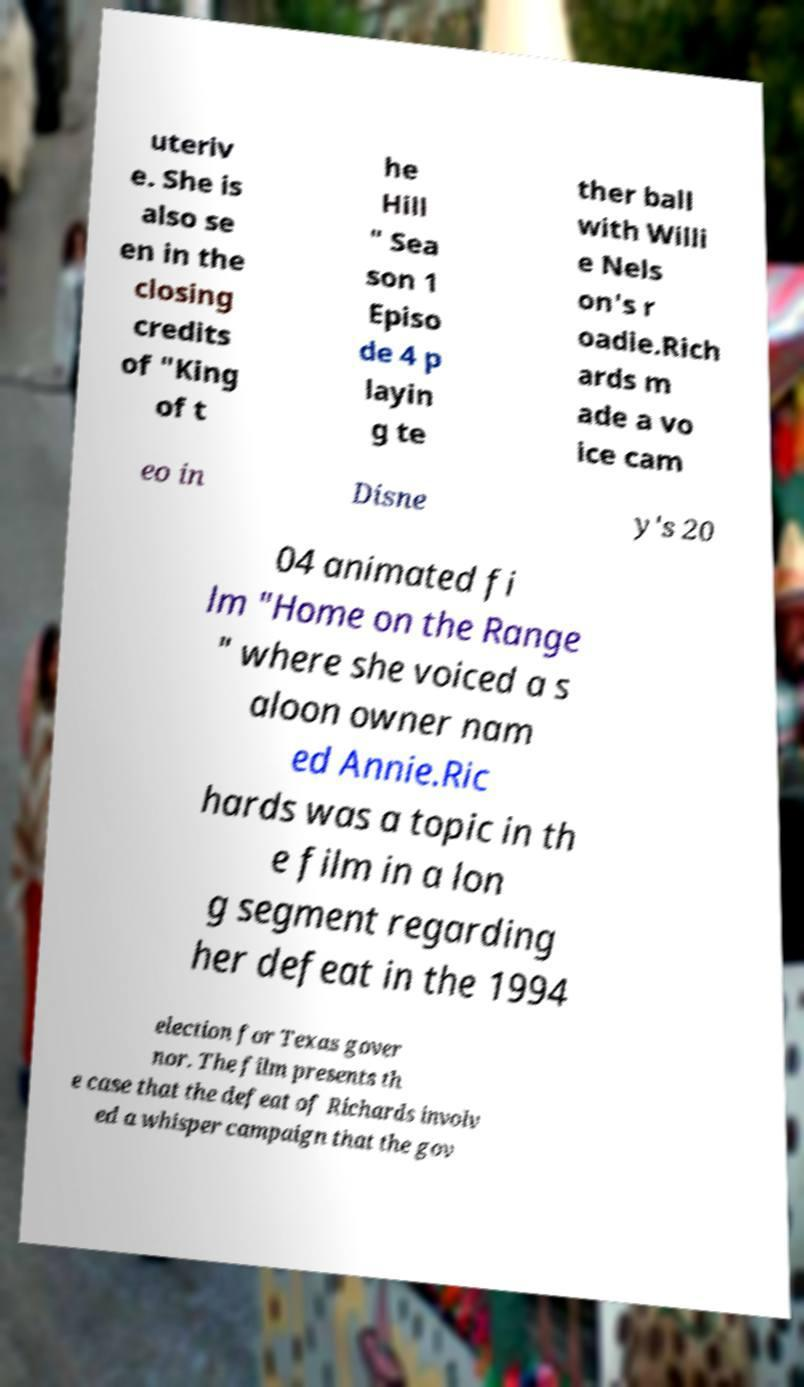Could you extract and type out the text from this image? uteriv e. She is also se en in the closing credits of "King of t he Hill " Sea son 1 Episo de 4 p layin g te ther ball with Willi e Nels on's r oadie.Rich ards m ade a vo ice cam eo in Disne y's 20 04 animated fi lm "Home on the Range " where she voiced a s aloon owner nam ed Annie.Ric hards was a topic in th e film in a lon g segment regarding her defeat in the 1994 election for Texas gover nor. The film presents th e case that the defeat of Richards involv ed a whisper campaign that the gov 